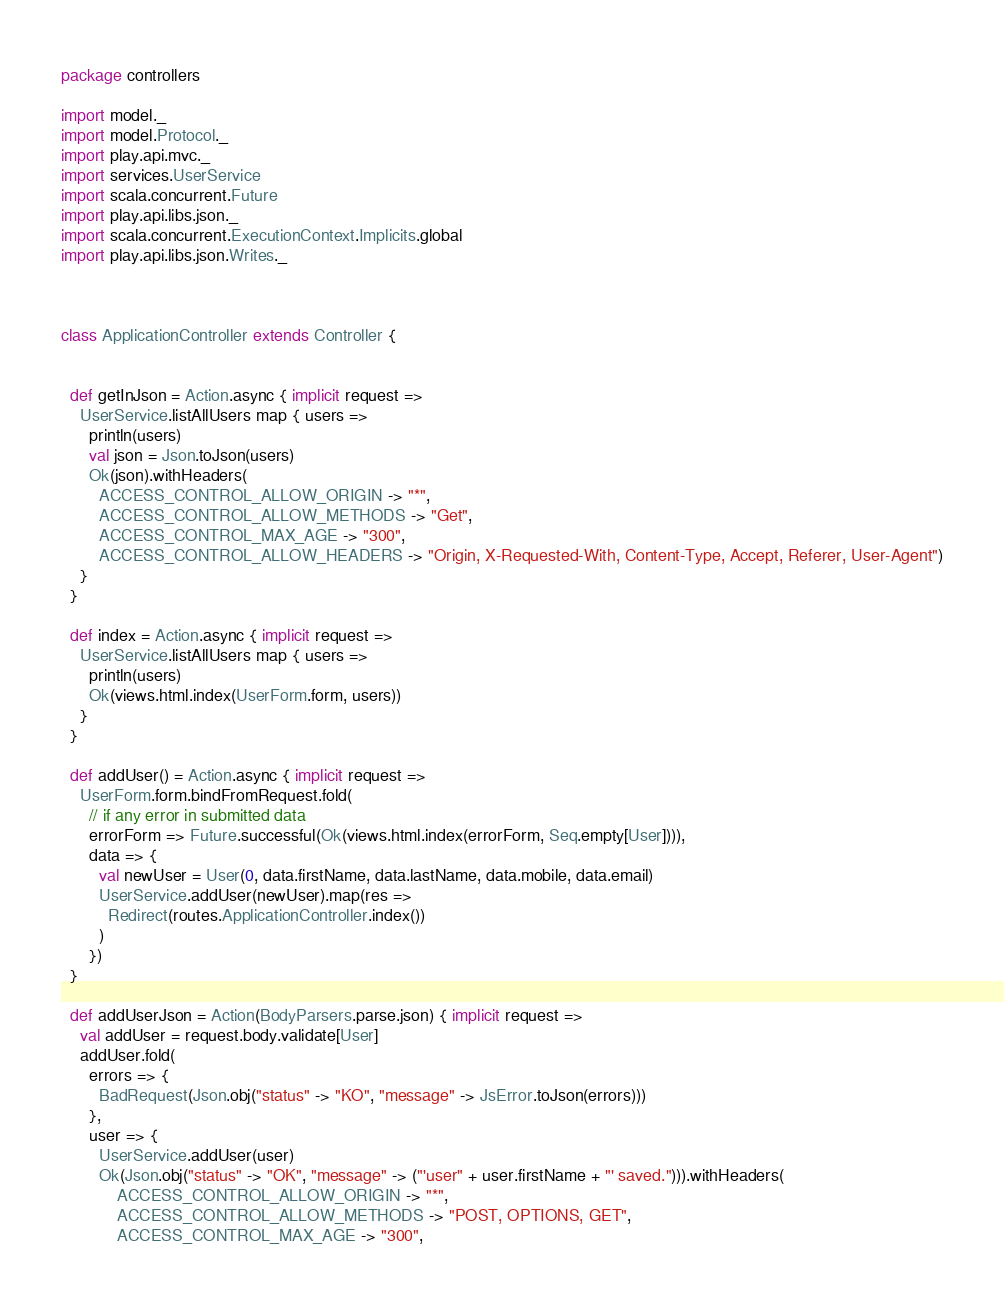<code> <loc_0><loc_0><loc_500><loc_500><_Scala_>package controllers

import model._
import model.Protocol._
import play.api.mvc._
import services.UserService
import scala.concurrent.Future
import play.api.libs.json._
import scala.concurrent.ExecutionContext.Implicits.global
import play.api.libs.json.Writes._



class ApplicationController extends Controller {


  def getInJson = Action.async { implicit request =>
    UserService.listAllUsers map { users =>
      println(users)
      val json = Json.toJson(users)
      Ok(json).withHeaders(
        ACCESS_CONTROL_ALLOW_ORIGIN -> "*",
        ACCESS_CONTROL_ALLOW_METHODS -> "Get",
        ACCESS_CONTROL_MAX_AGE -> "300",
        ACCESS_CONTROL_ALLOW_HEADERS -> "Origin, X-Requested-With, Content-Type, Accept, Referer, User-Agent")
    }
  }

  def index = Action.async { implicit request =>
    UserService.listAllUsers map { users =>
      println(users)
      Ok(views.html.index(UserForm.form, users))
    }
  }

  def addUser() = Action.async { implicit request =>
    UserForm.form.bindFromRequest.fold(
      // if any error in submitted data
      errorForm => Future.successful(Ok(views.html.index(errorForm, Seq.empty[User]))),
      data => {
        val newUser = User(0, data.firstName, data.lastName, data.mobile, data.email)
        UserService.addUser(newUser).map(res =>
          Redirect(routes.ApplicationController.index())
        )
      })
  }

  def addUserJson = Action(BodyParsers.parse.json) { implicit request =>
    val addUser = request.body.validate[User]
    addUser.fold(
      errors => {
        BadRequest(Json.obj("status" -> "KO", "message" -> JsError.toJson(errors)))
      },
      user => {
        UserService.addUser(user)
        Ok(Json.obj("status" -> "OK", "message" -> ("'user" + user.firstName + "' saved."))).withHeaders(
            ACCESS_CONTROL_ALLOW_ORIGIN -> "*",
            ACCESS_CONTROL_ALLOW_METHODS -> "POST, OPTIONS, GET",
            ACCESS_CONTROL_MAX_AGE -> "300",</code> 